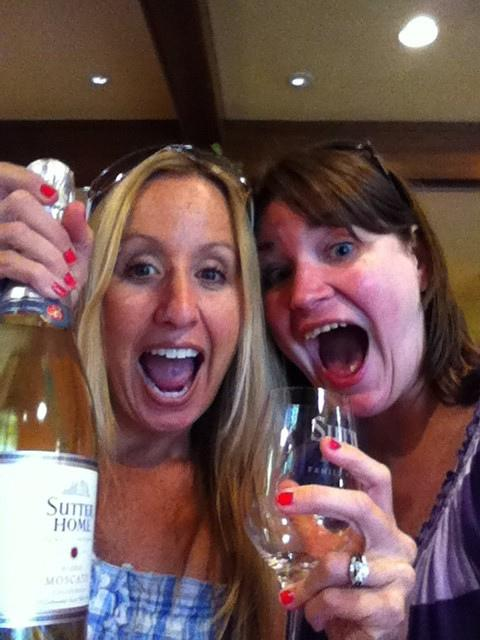What emotion are the woman exhibiting? happiness 